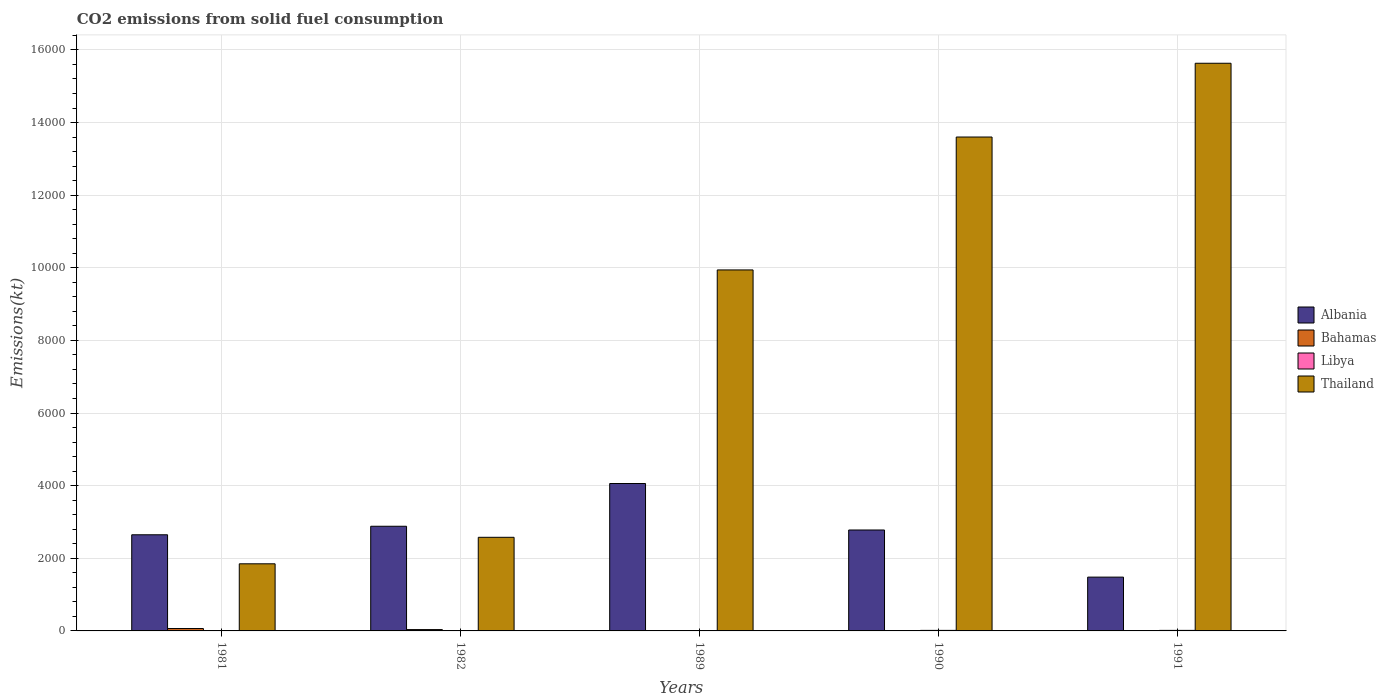How many different coloured bars are there?
Your response must be concise. 4. How many groups of bars are there?
Make the answer very short. 5. Are the number of bars per tick equal to the number of legend labels?
Keep it short and to the point. Yes. Are the number of bars on each tick of the X-axis equal?
Make the answer very short. Yes. How many bars are there on the 3rd tick from the left?
Give a very brief answer. 4. What is the amount of CO2 emitted in Libya in 1989?
Provide a short and direct response. 11. Across all years, what is the maximum amount of CO2 emitted in Libya?
Give a very brief answer. 14.67. Across all years, what is the minimum amount of CO2 emitted in Libya?
Your response must be concise. 3.67. In which year was the amount of CO2 emitted in Bahamas maximum?
Ensure brevity in your answer.  1981. What is the total amount of CO2 emitted in Albania in the graph?
Give a very brief answer. 1.39e+04. What is the difference between the amount of CO2 emitted in Thailand in 1981 and the amount of CO2 emitted in Bahamas in 1991?
Ensure brevity in your answer.  1844.5. What is the average amount of CO2 emitted in Albania per year?
Provide a succinct answer. 2770.05. In the year 1982, what is the difference between the amount of CO2 emitted in Libya and amount of CO2 emitted in Albania?
Give a very brief answer. -2878.6. In how many years, is the amount of CO2 emitted in Albania greater than 10000 kt?
Your answer should be compact. 0. Is the amount of CO2 emitted in Libya in 1982 less than that in 1989?
Your answer should be very brief. Yes. Is the difference between the amount of CO2 emitted in Libya in 1981 and 1982 greater than the difference between the amount of CO2 emitted in Albania in 1981 and 1982?
Your answer should be very brief. Yes. What is the difference between the highest and the second highest amount of CO2 emitted in Thailand?
Your answer should be compact. 2031.52. What is the difference between the highest and the lowest amount of CO2 emitted in Albania?
Ensure brevity in your answer.  2577.9. What does the 3rd bar from the left in 1981 represents?
Make the answer very short. Libya. What does the 1st bar from the right in 1989 represents?
Your response must be concise. Thailand. How many bars are there?
Keep it short and to the point. 20. Are all the bars in the graph horizontal?
Offer a terse response. No. How many legend labels are there?
Offer a very short reply. 4. What is the title of the graph?
Provide a succinct answer. CO2 emissions from solid fuel consumption. Does "Qatar" appear as one of the legend labels in the graph?
Your answer should be very brief. No. What is the label or title of the Y-axis?
Make the answer very short. Emissions(kt). What is the Emissions(kt) of Albania in 1981?
Provide a succinct answer. 2647.57. What is the Emissions(kt) in Bahamas in 1981?
Offer a very short reply. 66.01. What is the Emissions(kt) of Libya in 1981?
Your answer should be very brief. 3.67. What is the Emissions(kt) of Thailand in 1981?
Offer a terse response. 1848.17. What is the Emissions(kt) in Albania in 1982?
Your answer should be compact. 2882.26. What is the Emissions(kt) of Bahamas in 1982?
Provide a short and direct response. 36.67. What is the Emissions(kt) of Libya in 1982?
Ensure brevity in your answer.  3.67. What is the Emissions(kt) of Thailand in 1982?
Give a very brief answer. 2577.9. What is the Emissions(kt) of Albania in 1989?
Give a very brief answer. 4059.37. What is the Emissions(kt) of Bahamas in 1989?
Provide a short and direct response. 3.67. What is the Emissions(kt) of Libya in 1989?
Make the answer very short. 11. What is the Emissions(kt) in Thailand in 1989?
Your answer should be very brief. 9941.24. What is the Emissions(kt) of Albania in 1990?
Your response must be concise. 2779.59. What is the Emissions(kt) in Bahamas in 1990?
Provide a short and direct response. 3.67. What is the Emissions(kt) of Libya in 1990?
Ensure brevity in your answer.  14.67. What is the Emissions(kt) in Thailand in 1990?
Offer a very short reply. 1.36e+04. What is the Emissions(kt) in Albania in 1991?
Give a very brief answer. 1481.47. What is the Emissions(kt) of Bahamas in 1991?
Your answer should be very brief. 3.67. What is the Emissions(kt) of Libya in 1991?
Give a very brief answer. 14.67. What is the Emissions(kt) of Thailand in 1991?
Make the answer very short. 1.56e+04. Across all years, what is the maximum Emissions(kt) in Albania?
Your answer should be very brief. 4059.37. Across all years, what is the maximum Emissions(kt) of Bahamas?
Offer a very short reply. 66.01. Across all years, what is the maximum Emissions(kt) in Libya?
Your answer should be compact. 14.67. Across all years, what is the maximum Emissions(kt) of Thailand?
Ensure brevity in your answer.  1.56e+04. Across all years, what is the minimum Emissions(kt) of Albania?
Offer a very short reply. 1481.47. Across all years, what is the minimum Emissions(kt) of Bahamas?
Ensure brevity in your answer.  3.67. Across all years, what is the minimum Emissions(kt) in Libya?
Your answer should be very brief. 3.67. Across all years, what is the minimum Emissions(kt) in Thailand?
Make the answer very short. 1848.17. What is the total Emissions(kt) in Albania in the graph?
Keep it short and to the point. 1.39e+04. What is the total Emissions(kt) in Bahamas in the graph?
Provide a succinct answer. 113.68. What is the total Emissions(kt) of Libya in the graph?
Provide a short and direct response. 47.67. What is the total Emissions(kt) of Thailand in the graph?
Give a very brief answer. 4.36e+04. What is the difference between the Emissions(kt) in Albania in 1981 and that in 1982?
Keep it short and to the point. -234.69. What is the difference between the Emissions(kt) of Bahamas in 1981 and that in 1982?
Provide a short and direct response. 29.34. What is the difference between the Emissions(kt) of Thailand in 1981 and that in 1982?
Offer a very short reply. -729.73. What is the difference between the Emissions(kt) of Albania in 1981 and that in 1989?
Offer a terse response. -1411.8. What is the difference between the Emissions(kt) of Bahamas in 1981 and that in 1989?
Your answer should be very brief. 62.34. What is the difference between the Emissions(kt) of Libya in 1981 and that in 1989?
Provide a short and direct response. -7.33. What is the difference between the Emissions(kt) in Thailand in 1981 and that in 1989?
Ensure brevity in your answer.  -8093.07. What is the difference between the Emissions(kt) in Albania in 1981 and that in 1990?
Give a very brief answer. -132.01. What is the difference between the Emissions(kt) of Bahamas in 1981 and that in 1990?
Provide a short and direct response. 62.34. What is the difference between the Emissions(kt) of Libya in 1981 and that in 1990?
Your answer should be very brief. -11. What is the difference between the Emissions(kt) in Thailand in 1981 and that in 1990?
Keep it short and to the point. -1.18e+04. What is the difference between the Emissions(kt) of Albania in 1981 and that in 1991?
Provide a succinct answer. 1166.11. What is the difference between the Emissions(kt) in Bahamas in 1981 and that in 1991?
Offer a terse response. 62.34. What is the difference between the Emissions(kt) in Libya in 1981 and that in 1991?
Give a very brief answer. -11. What is the difference between the Emissions(kt) in Thailand in 1981 and that in 1991?
Keep it short and to the point. -1.38e+04. What is the difference between the Emissions(kt) of Albania in 1982 and that in 1989?
Keep it short and to the point. -1177.11. What is the difference between the Emissions(kt) of Bahamas in 1982 and that in 1989?
Provide a succinct answer. 33. What is the difference between the Emissions(kt) in Libya in 1982 and that in 1989?
Provide a succinct answer. -7.33. What is the difference between the Emissions(kt) in Thailand in 1982 and that in 1989?
Offer a terse response. -7363.34. What is the difference between the Emissions(kt) of Albania in 1982 and that in 1990?
Keep it short and to the point. 102.68. What is the difference between the Emissions(kt) in Bahamas in 1982 and that in 1990?
Offer a terse response. 33. What is the difference between the Emissions(kt) in Libya in 1982 and that in 1990?
Your response must be concise. -11. What is the difference between the Emissions(kt) of Thailand in 1982 and that in 1990?
Provide a short and direct response. -1.10e+04. What is the difference between the Emissions(kt) in Albania in 1982 and that in 1991?
Provide a succinct answer. 1400.79. What is the difference between the Emissions(kt) of Bahamas in 1982 and that in 1991?
Offer a very short reply. 33. What is the difference between the Emissions(kt) in Libya in 1982 and that in 1991?
Offer a very short reply. -11. What is the difference between the Emissions(kt) in Thailand in 1982 and that in 1991?
Your response must be concise. -1.31e+04. What is the difference between the Emissions(kt) in Albania in 1989 and that in 1990?
Offer a terse response. 1279.78. What is the difference between the Emissions(kt) in Libya in 1989 and that in 1990?
Offer a terse response. -3.67. What is the difference between the Emissions(kt) of Thailand in 1989 and that in 1990?
Your response must be concise. -3659.67. What is the difference between the Emissions(kt) in Albania in 1989 and that in 1991?
Make the answer very short. 2577.9. What is the difference between the Emissions(kt) of Libya in 1989 and that in 1991?
Offer a terse response. -3.67. What is the difference between the Emissions(kt) of Thailand in 1989 and that in 1991?
Provide a succinct answer. -5691.18. What is the difference between the Emissions(kt) in Albania in 1990 and that in 1991?
Your answer should be very brief. 1298.12. What is the difference between the Emissions(kt) of Bahamas in 1990 and that in 1991?
Make the answer very short. 0. What is the difference between the Emissions(kt) of Libya in 1990 and that in 1991?
Your answer should be very brief. 0. What is the difference between the Emissions(kt) in Thailand in 1990 and that in 1991?
Your response must be concise. -2031.52. What is the difference between the Emissions(kt) in Albania in 1981 and the Emissions(kt) in Bahamas in 1982?
Your response must be concise. 2610.9. What is the difference between the Emissions(kt) of Albania in 1981 and the Emissions(kt) of Libya in 1982?
Make the answer very short. 2643.91. What is the difference between the Emissions(kt) of Albania in 1981 and the Emissions(kt) of Thailand in 1982?
Make the answer very short. 69.67. What is the difference between the Emissions(kt) in Bahamas in 1981 and the Emissions(kt) in Libya in 1982?
Keep it short and to the point. 62.34. What is the difference between the Emissions(kt) in Bahamas in 1981 and the Emissions(kt) in Thailand in 1982?
Your response must be concise. -2511.89. What is the difference between the Emissions(kt) of Libya in 1981 and the Emissions(kt) of Thailand in 1982?
Ensure brevity in your answer.  -2574.23. What is the difference between the Emissions(kt) of Albania in 1981 and the Emissions(kt) of Bahamas in 1989?
Make the answer very short. 2643.91. What is the difference between the Emissions(kt) in Albania in 1981 and the Emissions(kt) in Libya in 1989?
Your answer should be compact. 2636.57. What is the difference between the Emissions(kt) of Albania in 1981 and the Emissions(kt) of Thailand in 1989?
Give a very brief answer. -7293.66. What is the difference between the Emissions(kt) of Bahamas in 1981 and the Emissions(kt) of Libya in 1989?
Ensure brevity in your answer.  55.01. What is the difference between the Emissions(kt) in Bahamas in 1981 and the Emissions(kt) in Thailand in 1989?
Offer a terse response. -9875.23. What is the difference between the Emissions(kt) in Libya in 1981 and the Emissions(kt) in Thailand in 1989?
Ensure brevity in your answer.  -9937.57. What is the difference between the Emissions(kt) of Albania in 1981 and the Emissions(kt) of Bahamas in 1990?
Keep it short and to the point. 2643.91. What is the difference between the Emissions(kt) in Albania in 1981 and the Emissions(kt) in Libya in 1990?
Keep it short and to the point. 2632.91. What is the difference between the Emissions(kt) in Albania in 1981 and the Emissions(kt) in Thailand in 1990?
Your answer should be very brief. -1.10e+04. What is the difference between the Emissions(kt) in Bahamas in 1981 and the Emissions(kt) in Libya in 1990?
Provide a short and direct response. 51.34. What is the difference between the Emissions(kt) of Bahamas in 1981 and the Emissions(kt) of Thailand in 1990?
Keep it short and to the point. -1.35e+04. What is the difference between the Emissions(kt) of Libya in 1981 and the Emissions(kt) of Thailand in 1990?
Keep it short and to the point. -1.36e+04. What is the difference between the Emissions(kt) of Albania in 1981 and the Emissions(kt) of Bahamas in 1991?
Provide a succinct answer. 2643.91. What is the difference between the Emissions(kt) of Albania in 1981 and the Emissions(kt) of Libya in 1991?
Provide a succinct answer. 2632.91. What is the difference between the Emissions(kt) in Albania in 1981 and the Emissions(kt) in Thailand in 1991?
Offer a terse response. -1.30e+04. What is the difference between the Emissions(kt) in Bahamas in 1981 and the Emissions(kt) in Libya in 1991?
Provide a succinct answer. 51.34. What is the difference between the Emissions(kt) in Bahamas in 1981 and the Emissions(kt) in Thailand in 1991?
Make the answer very short. -1.56e+04. What is the difference between the Emissions(kt) of Libya in 1981 and the Emissions(kt) of Thailand in 1991?
Provide a short and direct response. -1.56e+04. What is the difference between the Emissions(kt) in Albania in 1982 and the Emissions(kt) in Bahamas in 1989?
Ensure brevity in your answer.  2878.59. What is the difference between the Emissions(kt) in Albania in 1982 and the Emissions(kt) in Libya in 1989?
Provide a succinct answer. 2871.26. What is the difference between the Emissions(kt) in Albania in 1982 and the Emissions(kt) in Thailand in 1989?
Offer a very short reply. -7058.98. What is the difference between the Emissions(kt) of Bahamas in 1982 and the Emissions(kt) of Libya in 1989?
Give a very brief answer. 25.67. What is the difference between the Emissions(kt) of Bahamas in 1982 and the Emissions(kt) of Thailand in 1989?
Keep it short and to the point. -9904.57. What is the difference between the Emissions(kt) in Libya in 1982 and the Emissions(kt) in Thailand in 1989?
Your response must be concise. -9937.57. What is the difference between the Emissions(kt) of Albania in 1982 and the Emissions(kt) of Bahamas in 1990?
Provide a succinct answer. 2878.59. What is the difference between the Emissions(kt) of Albania in 1982 and the Emissions(kt) of Libya in 1990?
Make the answer very short. 2867.59. What is the difference between the Emissions(kt) in Albania in 1982 and the Emissions(kt) in Thailand in 1990?
Your answer should be compact. -1.07e+04. What is the difference between the Emissions(kt) of Bahamas in 1982 and the Emissions(kt) of Libya in 1990?
Your response must be concise. 22. What is the difference between the Emissions(kt) of Bahamas in 1982 and the Emissions(kt) of Thailand in 1990?
Your answer should be very brief. -1.36e+04. What is the difference between the Emissions(kt) in Libya in 1982 and the Emissions(kt) in Thailand in 1990?
Give a very brief answer. -1.36e+04. What is the difference between the Emissions(kt) of Albania in 1982 and the Emissions(kt) of Bahamas in 1991?
Offer a very short reply. 2878.59. What is the difference between the Emissions(kt) of Albania in 1982 and the Emissions(kt) of Libya in 1991?
Make the answer very short. 2867.59. What is the difference between the Emissions(kt) of Albania in 1982 and the Emissions(kt) of Thailand in 1991?
Ensure brevity in your answer.  -1.28e+04. What is the difference between the Emissions(kt) in Bahamas in 1982 and the Emissions(kt) in Libya in 1991?
Offer a terse response. 22. What is the difference between the Emissions(kt) in Bahamas in 1982 and the Emissions(kt) in Thailand in 1991?
Provide a short and direct response. -1.56e+04. What is the difference between the Emissions(kt) in Libya in 1982 and the Emissions(kt) in Thailand in 1991?
Provide a succinct answer. -1.56e+04. What is the difference between the Emissions(kt) of Albania in 1989 and the Emissions(kt) of Bahamas in 1990?
Give a very brief answer. 4055.7. What is the difference between the Emissions(kt) in Albania in 1989 and the Emissions(kt) in Libya in 1990?
Keep it short and to the point. 4044.7. What is the difference between the Emissions(kt) of Albania in 1989 and the Emissions(kt) of Thailand in 1990?
Provide a short and direct response. -9541.53. What is the difference between the Emissions(kt) of Bahamas in 1989 and the Emissions(kt) of Libya in 1990?
Offer a very short reply. -11. What is the difference between the Emissions(kt) in Bahamas in 1989 and the Emissions(kt) in Thailand in 1990?
Ensure brevity in your answer.  -1.36e+04. What is the difference between the Emissions(kt) in Libya in 1989 and the Emissions(kt) in Thailand in 1990?
Keep it short and to the point. -1.36e+04. What is the difference between the Emissions(kt) of Albania in 1989 and the Emissions(kt) of Bahamas in 1991?
Provide a succinct answer. 4055.7. What is the difference between the Emissions(kt) of Albania in 1989 and the Emissions(kt) of Libya in 1991?
Your answer should be compact. 4044.7. What is the difference between the Emissions(kt) in Albania in 1989 and the Emissions(kt) in Thailand in 1991?
Offer a terse response. -1.16e+04. What is the difference between the Emissions(kt) in Bahamas in 1989 and the Emissions(kt) in Libya in 1991?
Your answer should be very brief. -11. What is the difference between the Emissions(kt) of Bahamas in 1989 and the Emissions(kt) of Thailand in 1991?
Give a very brief answer. -1.56e+04. What is the difference between the Emissions(kt) in Libya in 1989 and the Emissions(kt) in Thailand in 1991?
Give a very brief answer. -1.56e+04. What is the difference between the Emissions(kt) in Albania in 1990 and the Emissions(kt) in Bahamas in 1991?
Offer a terse response. 2775.92. What is the difference between the Emissions(kt) of Albania in 1990 and the Emissions(kt) of Libya in 1991?
Your answer should be very brief. 2764.92. What is the difference between the Emissions(kt) of Albania in 1990 and the Emissions(kt) of Thailand in 1991?
Ensure brevity in your answer.  -1.29e+04. What is the difference between the Emissions(kt) in Bahamas in 1990 and the Emissions(kt) in Libya in 1991?
Your answer should be very brief. -11. What is the difference between the Emissions(kt) in Bahamas in 1990 and the Emissions(kt) in Thailand in 1991?
Offer a terse response. -1.56e+04. What is the difference between the Emissions(kt) of Libya in 1990 and the Emissions(kt) of Thailand in 1991?
Ensure brevity in your answer.  -1.56e+04. What is the average Emissions(kt) of Albania per year?
Your response must be concise. 2770.05. What is the average Emissions(kt) in Bahamas per year?
Give a very brief answer. 22.74. What is the average Emissions(kt) in Libya per year?
Your response must be concise. 9.53. What is the average Emissions(kt) in Thailand per year?
Ensure brevity in your answer.  8720.13. In the year 1981, what is the difference between the Emissions(kt) in Albania and Emissions(kt) in Bahamas?
Provide a succinct answer. 2581.57. In the year 1981, what is the difference between the Emissions(kt) of Albania and Emissions(kt) of Libya?
Your response must be concise. 2643.91. In the year 1981, what is the difference between the Emissions(kt) in Albania and Emissions(kt) in Thailand?
Offer a very short reply. 799.41. In the year 1981, what is the difference between the Emissions(kt) in Bahamas and Emissions(kt) in Libya?
Give a very brief answer. 62.34. In the year 1981, what is the difference between the Emissions(kt) in Bahamas and Emissions(kt) in Thailand?
Your answer should be compact. -1782.16. In the year 1981, what is the difference between the Emissions(kt) in Libya and Emissions(kt) in Thailand?
Your response must be concise. -1844.5. In the year 1982, what is the difference between the Emissions(kt) in Albania and Emissions(kt) in Bahamas?
Keep it short and to the point. 2845.59. In the year 1982, what is the difference between the Emissions(kt) in Albania and Emissions(kt) in Libya?
Make the answer very short. 2878.59. In the year 1982, what is the difference between the Emissions(kt) of Albania and Emissions(kt) of Thailand?
Provide a short and direct response. 304.36. In the year 1982, what is the difference between the Emissions(kt) of Bahamas and Emissions(kt) of Libya?
Provide a short and direct response. 33. In the year 1982, what is the difference between the Emissions(kt) in Bahamas and Emissions(kt) in Thailand?
Your answer should be compact. -2541.23. In the year 1982, what is the difference between the Emissions(kt) of Libya and Emissions(kt) of Thailand?
Give a very brief answer. -2574.23. In the year 1989, what is the difference between the Emissions(kt) in Albania and Emissions(kt) in Bahamas?
Offer a terse response. 4055.7. In the year 1989, what is the difference between the Emissions(kt) in Albania and Emissions(kt) in Libya?
Keep it short and to the point. 4048.37. In the year 1989, what is the difference between the Emissions(kt) in Albania and Emissions(kt) in Thailand?
Ensure brevity in your answer.  -5881.87. In the year 1989, what is the difference between the Emissions(kt) of Bahamas and Emissions(kt) of Libya?
Ensure brevity in your answer.  -7.33. In the year 1989, what is the difference between the Emissions(kt) in Bahamas and Emissions(kt) in Thailand?
Your response must be concise. -9937.57. In the year 1989, what is the difference between the Emissions(kt) in Libya and Emissions(kt) in Thailand?
Your answer should be compact. -9930.24. In the year 1990, what is the difference between the Emissions(kt) in Albania and Emissions(kt) in Bahamas?
Offer a very short reply. 2775.92. In the year 1990, what is the difference between the Emissions(kt) in Albania and Emissions(kt) in Libya?
Offer a terse response. 2764.92. In the year 1990, what is the difference between the Emissions(kt) of Albania and Emissions(kt) of Thailand?
Offer a terse response. -1.08e+04. In the year 1990, what is the difference between the Emissions(kt) in Bahamas and Emissions(kt) in Libya?
Give a very brief answer. -11. In the year 1990, what is the difference between the Emissions(kt) of Bahamas and Emissions(kt) of Thailand?
Keep it short and to the point. -1.36e+04. In the year 1990, what is the difference between the Emissions(kt) of Libya and Emissions(kt) of Thailand?
Offer a terse response. -1.36e+04. In the year 1991, what is the difference between the Emissions(kt) in Albania and Emissions(kt) in Bahamas?
Give a very brief answer. 1477.8. In the year 1991, what is the difference between the Emissions(kt) in Albania and Emissions(kt) in Libya?
Your response must be concise. 1466.8. In the year 1991, what is the difference between the Emissions(kt) in Albania and Emissions(kt) in Thailand?
Make the answer very short. -1.42e+04. In the year 1991, what is the difference between the Emissions(kt) in Bahamas and Emissions(kt) in Libya?
Your answer should be compact. -11. In the year 1991, what is the difference between the Emissions(kt) in Bahamas and Emissions(kt) in Thailand?
Provide a short and direct response. -1.56e+04. In the year 1991, what is the difference between the Emissions(kt) in Libya and Emissions(kt) in Thailand?
Offer a terse response. -1.56e+04. What is the ratio of the Emissions(kt) in Albania in 1981 to that in 1982?
Ensure brevity in your answer.  0.92. What is the ratio of the Emissions(kt) of Thailand in 1981 to that in 1982?
Your response must be concise. 0.72. What is the ratio of the Emissions(kt) in Albania in 1981 to that in 1989?
Your answer should be very brief. 0.65. What is the ratio of the Emissions(kt) in Bahamas in 1981 to that in 1989?
Keep it short and to the point. 18. What is the ratio of the Emissions(kt) of Libya in 1981 to that in 1989?
Provide a short and direct response. 0.33. What is the ratio of the Emissions(kt) in Thailand in 1981 to that in 1989?
Offer a very short reply. 0.19. What is the ratio of the Emissions(kt) of Albania in 1981 to that in 1990?
Offer a terse response. 0.95. What is the ratio of the Emissions(kt) in Libya in 1981 to that in 1990?
Keep it short and to the point. 0.25. What is the ratio of the Emissions(kt) of Thailand in 1981 to that in 1990?
Give a very brief answer. 0.14. What is the ratio of the Emissions(kt) of Albania in 1981 to that in 1991?
Your answer should be very brief. 1.79. What is the ratio of the Emissions(kt) in Thailand in 1981 to that in 1991?
Your answer should be very brief. 0.12. What is the ratio of the Emissions(kt) in Albania in 1982 to that in 1989?
Provide a succinct answer. 0.71. What is the ratio of the Emissions(kt) of Thailand in 1982 to that in 1989?
Ensure brevity in your answer.  0.26. What is the ratio of the Emissions(kt) of Albania in 1982 to that in 1990?
Your answer should be compact. 1.04. What is the ratio of the Emissions(kt) of Bahamas in 1982 to that in 1990?
Provide a succinct answer. 10. What is the ratio of the Emissions(kt) of Thailand in 1982 to that in 1990?
Provide a succinct answer. 0.19. What is the ratio of the Emissions(kt) in Albania in 1982 to that in 1991?
Provide a short and direct response. 1.95. What is the ratio of the Emissions(kt) of Bahamas in 1982 to that in 1991?
Make the answer very short. 10. What is the ratio of the Emissions(kt) in Libya in 1982 to that in 1991?
Make the answer very short. 0.25. What is the ratio of the Emissions(kt) of Thailand in 1982 to that in 1991?
Your answer should be very brief. 0.16. What is the ratio of the Emissions(kt) of Albania in 1989 to that in 1990?
Your response must be concise. 1.46. What is the ratio of the Emissions(kt) in Thailand in 1989 to that in 1990?
Offer a terse response. 0.73. What is the ratio of the Emissions(kt) of Albania in 1989 to that in 1991?
Keep it short and to the point. 2.74. What is the ratio of the Emissions(kt) of Thailand in 1989 to that in 1991?
Make the answer very short. 0.64. What is the ratio of the Emissions(kt) of Albania in 1990 to that in 1991?
Provide a short and direct response. 1.88. What is the ratio of the Emissions(kt) of Bahamas in 1990 to that in 1991?
Make the answer very short. 1. What is the ratio of the Emissions(kt) in Thailand in 1990 to that in 1991?
Your response must be concise. 0.87. What is the difference between the highest and the second highest Emissions(kt) in Albania?
Keep it short and to the point. 1177.11. What is the difference between the highest and the second highest Emissions(kt) of Bahamas?
Your answer should be compact. 29.34. What is the difference between the highest and the second highest Emissions(kt) of Libya?
Keep it short and to the point. 0. What is the difference between the highest and the second highest Emissions(kt) in Thailand?
Your response must be concise. 2031.52. What is the difference between the highest and the lowest Emissions(kt) in Albania?
Your response must be concise. 2577.9. What is the difference between the highest and the lowest Emissions(kt) in Bahamas?
Your answer should be compact. 62.34. What is the difference between the highest and the lowest Emissions(kt) of Libya?
Your response must be concise. 11. What is the difference between the highest and the lowest Emissions(kt) in Thailand?
Make the answer very short. 1.38e+04. 